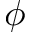<formula> <loc_0><loc_0><loc_500><loc_500>\phi</formula> 